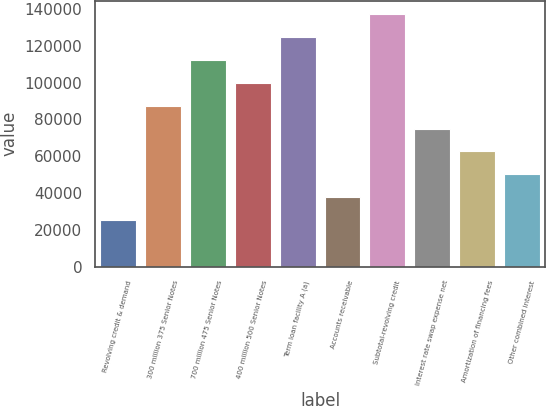<chart> <loc_0><loc_0><loc_500><loc_500><bar_chart><fcel>Revolving credit & demand<fcel>300 million 375 Senior Notes<fcel>700 million 475 Senior Notes<fcel>400 million 500 Senior Notes<fcel>Term loan facility A (a)<fcel>Accounts receivable<fcel>Subtotal-revolving credit<fcel>Interest rate swap expense net<fcel>Amortization of financing fees<fcel>Other combined interest<nl><fcel>25130.6<fcel>87582.1<fcel>112563<fcel>100072<fcel>125053<fcel>37620.9<fcel>137543<fcel>75091.8<fcel>62601.5<fcel>50111.2<nl></chart> 